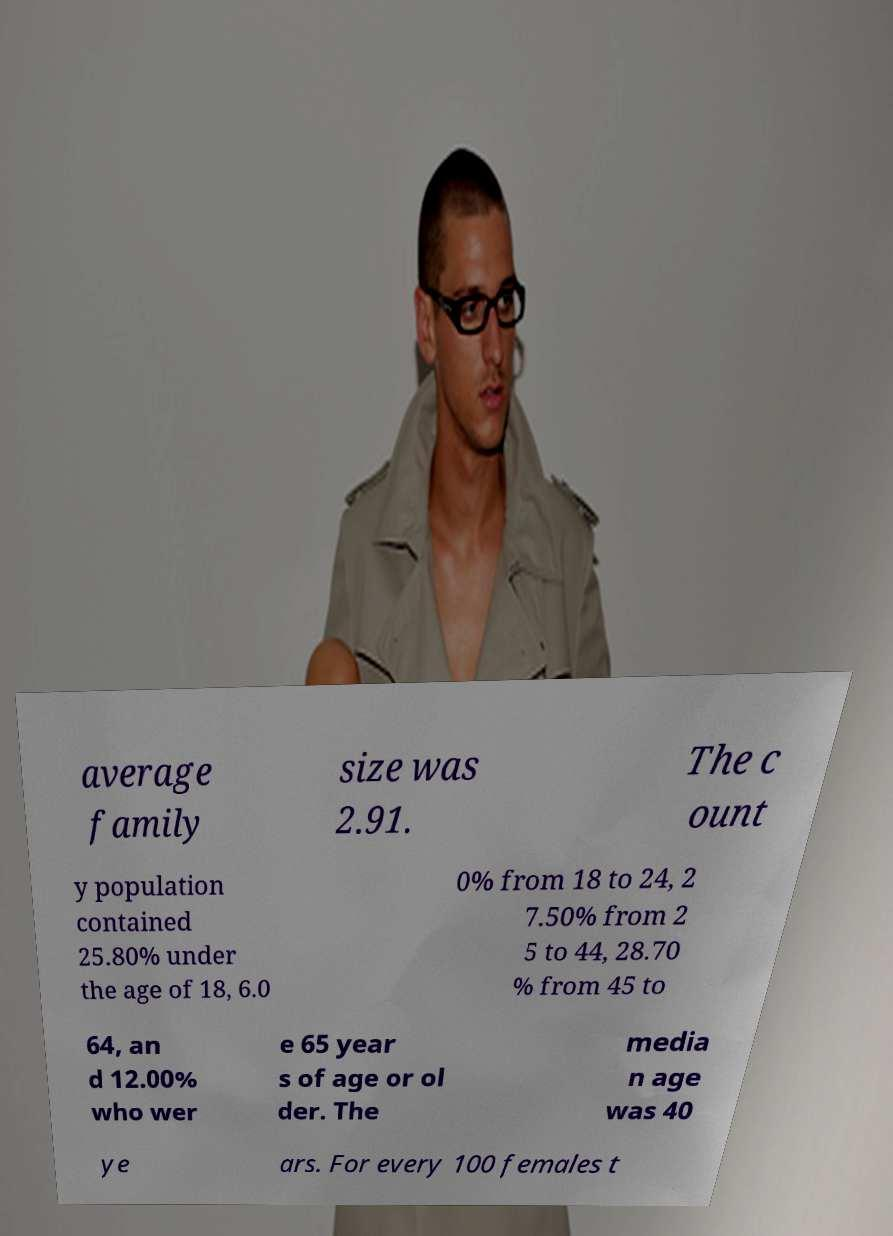Could you extract and type out the text from this image? average family size was 2.91. The c ount y population contained 25.80% under the age of 18, 6.0 0% from 18 to 24, 2 7.50% from 2 5 to 44, 28.70 % from 45 to 64, an d 12.00% who wer e 65 year s of age or ol der. The media n age was 40 ye ars. For every 100 females t 